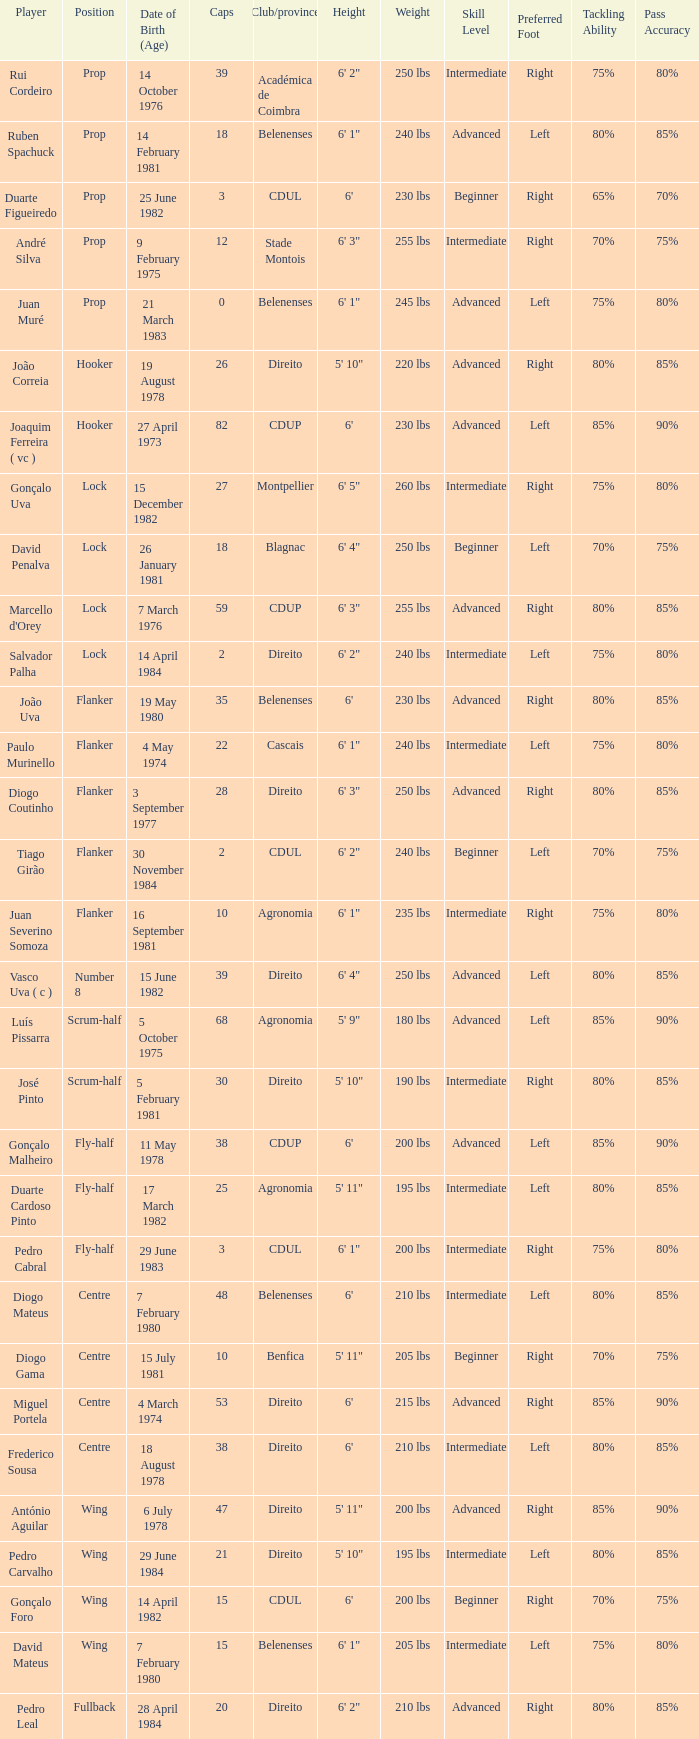How many caps have a Date of Birth (Age) of 15 july 1981? 1.0. 